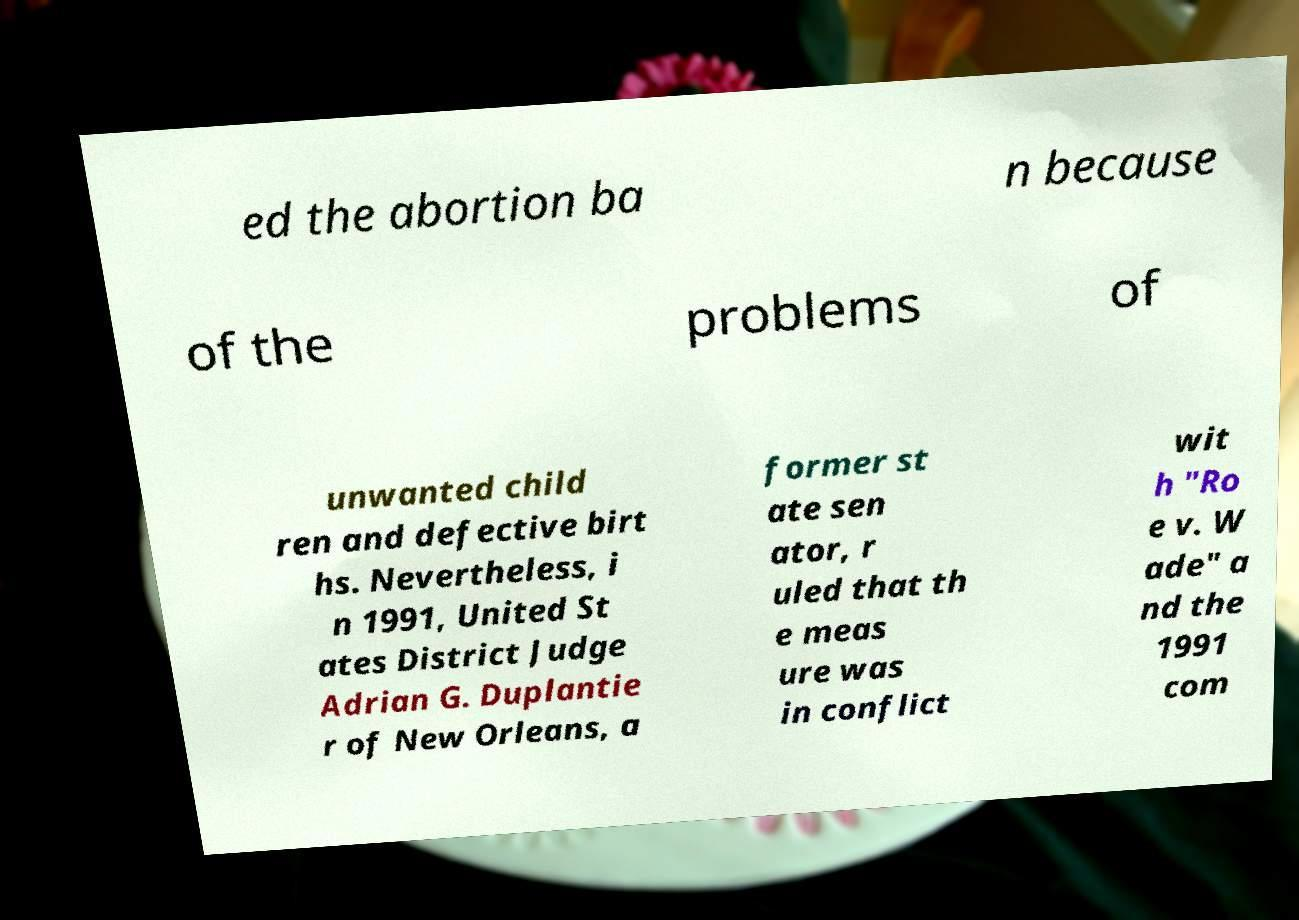Can you accurately transcribe the text from the provided image for me? ed the abortion ba n because of the problems of unwanted child ren and defective birt hs. Nevertheless, i n 1991, United St ates District Judge Adrian G. Duplantie r of New Orleans, a former st ate sen ator, r uled that th e meas ure was in conflict wit h "Ro e v. W ade" a nd the 1991 com 